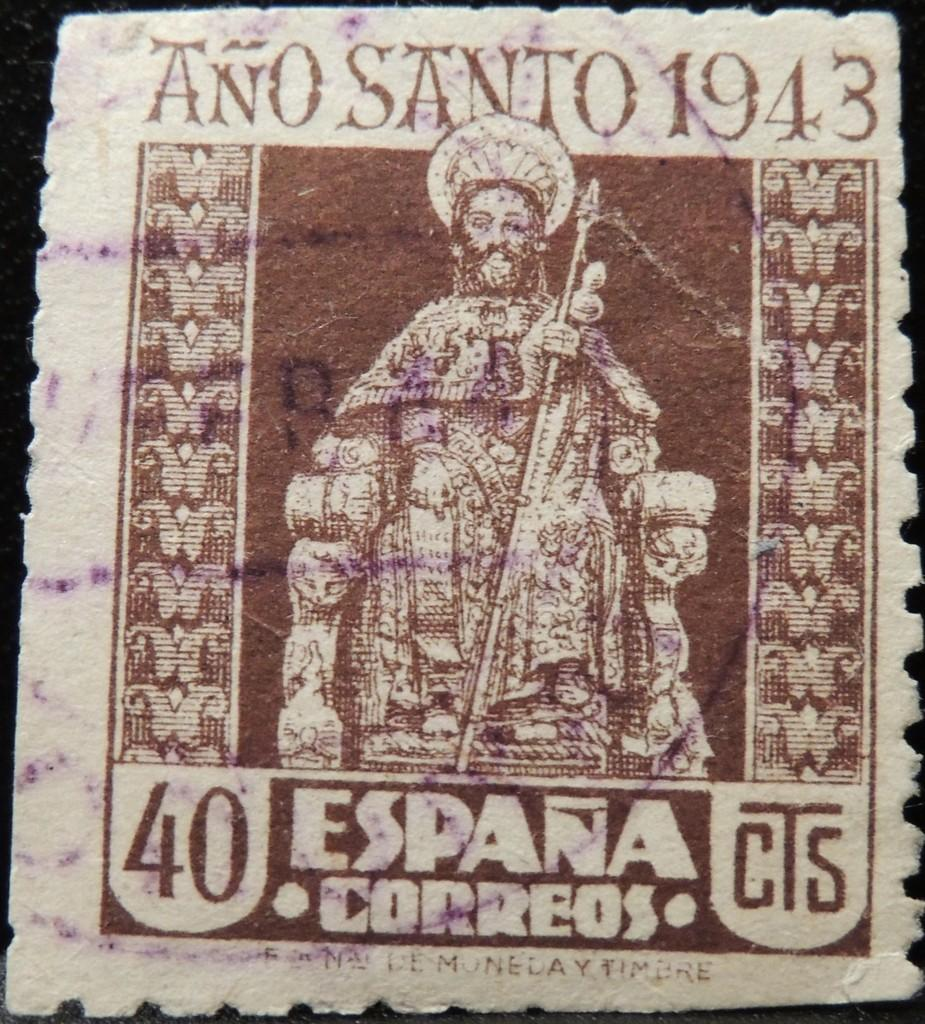What is present in the image that contains information or a message? There is a poster in the image that contains text. Can you describe the content of the poster? The poster features a person. Can you see any mountains or horses in the image? No, there are no mountains or horses present in the image. 